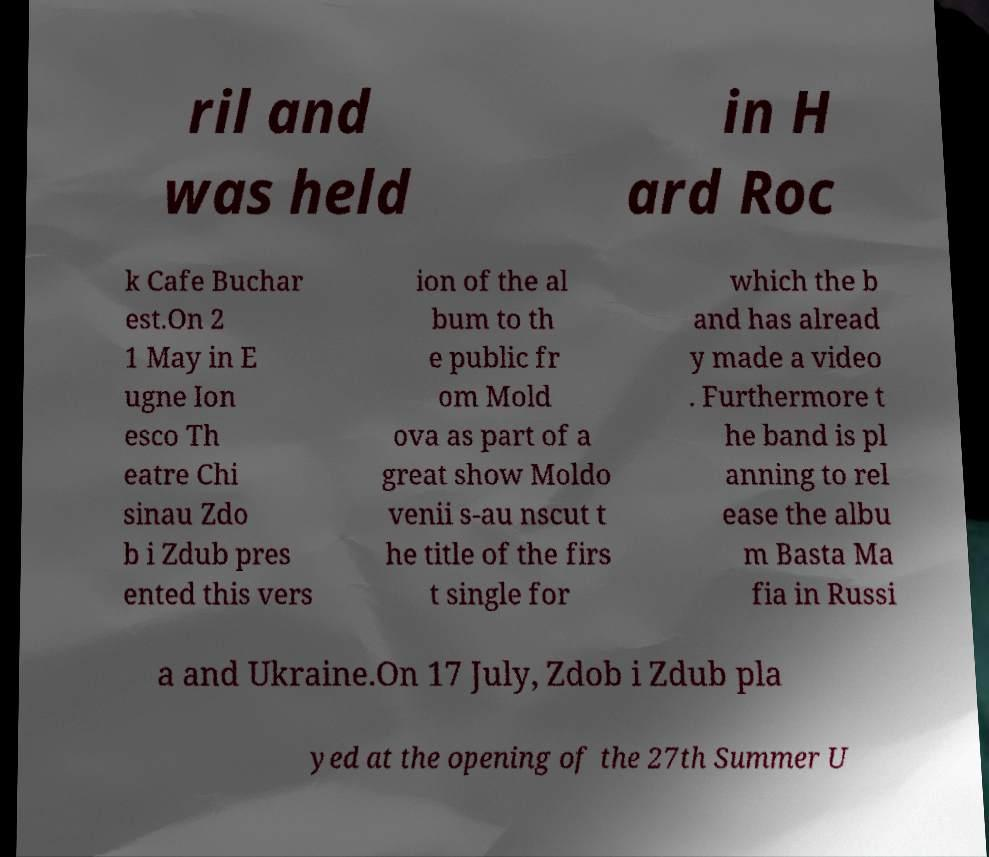Could you extract and type out the text from this image? ril and was held in H ard Roc k Cafe Buchar est.On 2 1 May in E ugne Ion esco Th eatre Chi sinau Zdo b i Zdub pres ented this vers ion of the al bum to th e public fr om Mold ova as part of a great show Moldo venii s-au nscut t he title of the firs t single for which the b and has alread y made a video . Furthermore t he band is pl anning to rel ease the albu m Basta Ma fia in Russi a and Ukraine.On 17 July, Zdob i Zdub pla yed at the opening of the 27th Summer U 